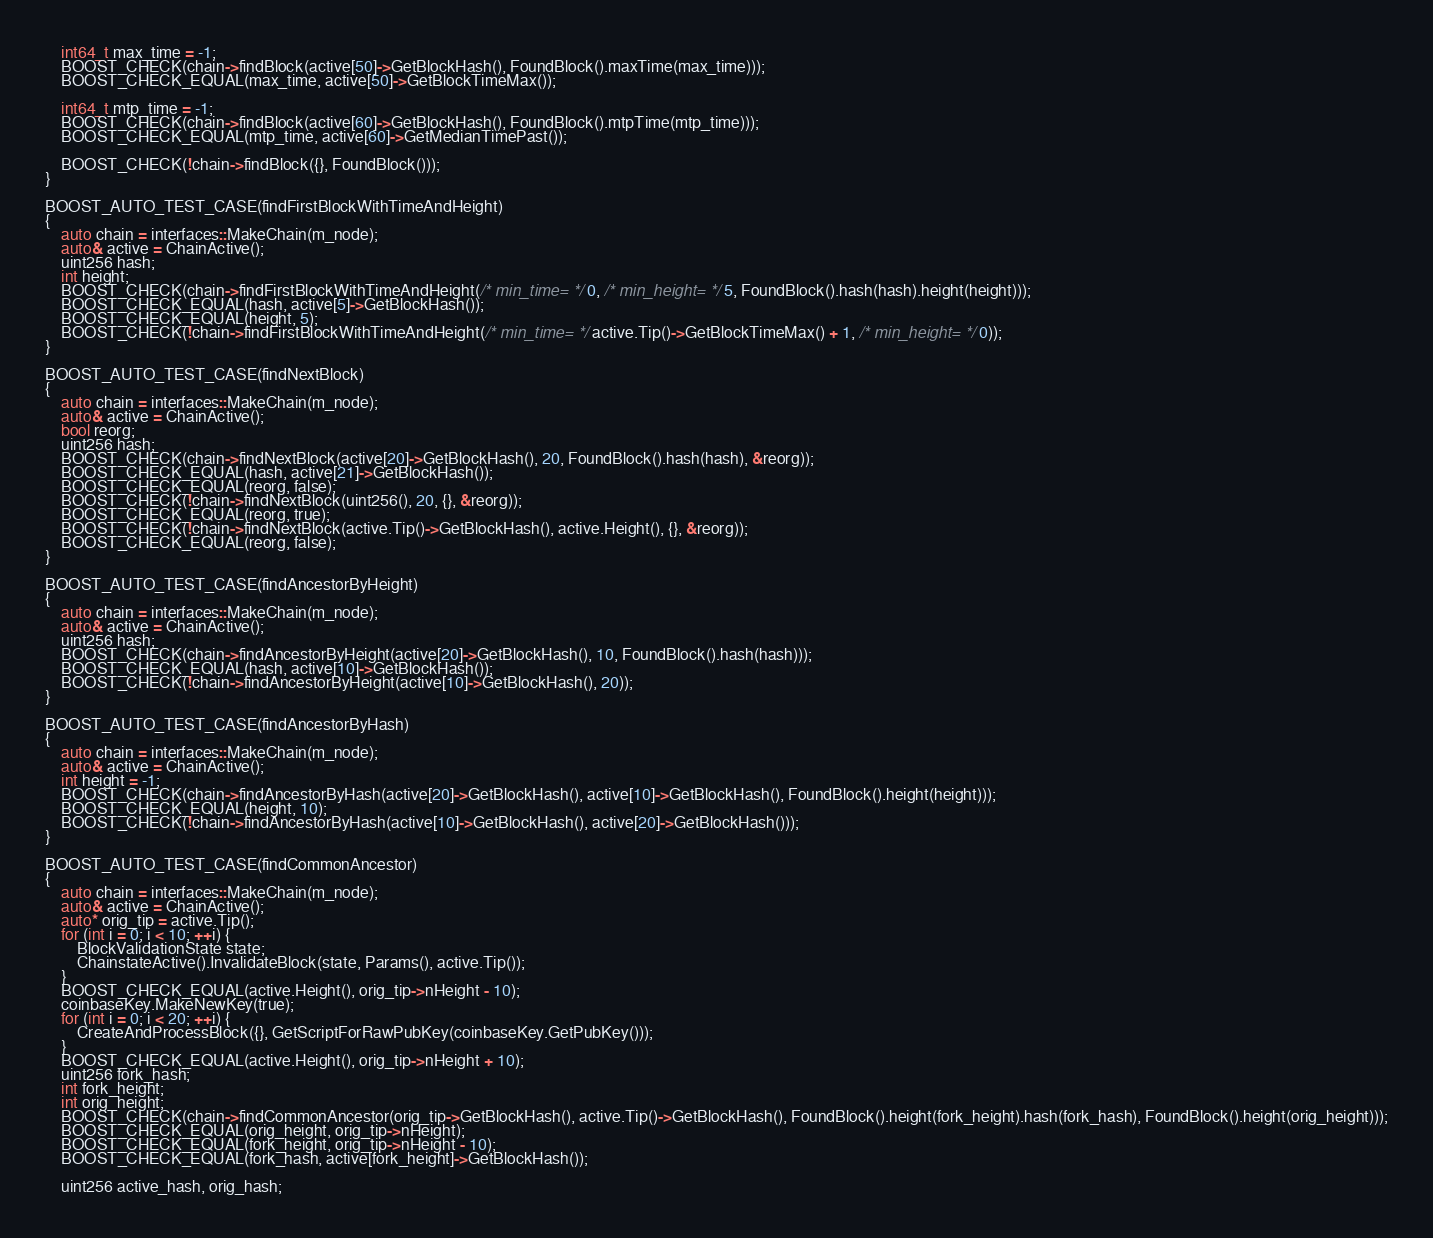Convert code to text. <code><loc_0><loc_0><loc_500><loc_500><_C++_>    int64_t max_time = -1;
    BOOST_CHECK(chain->findBlock(active[50]->GetBlockHash(), FoundBlock().maxTime(max_time)));
    BOOST_CHECK_EQUAL(max_time, active[50]->GetBlockTimeMax());

    int64_t mtp_time = -1;
    BOOST_CHECK(chain->findBlock(active[60]->GetBlockHash(), FoundBlock().mtpTime(mtp_time)));
    BOOST_CHECK_EQUAL(mtp_time, active[60]->GetMedianTimePast());

    BOOST_CHECK(!chain->findBlock({}, FoundBlock()));
}

BOOST_AUTO_TEST_CASE(findFirstBlockWithTimeAndHeight)
{
    auto chain = interfaces::MakeChain(m_node);
    auto& active = ChainActive();
    uint256 hash;
    int height;
    BOOST_CHECK(chain->findFirstBlockWithTimeAndHeight(/* min_time= */ 0, /* min_height= */ 5, FoundBlock().hash(hash).height(height)));
    BOOST_CHECK_EQUAL(hash, active[5]->GetBlockHash());
    BOOST_CHECK_EQUAL(height, 5);
    BOOST_CHECK(!chain->findFirstBlockWithTimeAndHeight(/* min_time= */ active.Tip()->GetBlockTimeMax() + 1, /* min_height= */ 0));
}

BOOST_AUTO_TEST_CASE(findNextBlock)
{
    auto chain = interfaces::MakeChain(m_node);
    auto& active = ChainActive();
    bool reorg;
    uint256 hash;
    BOOST_CHECK(chain->findNextBlock(active[20]->GetBlockHash(), 20, FoundBlock().hash(hash), &reorg));
    BOOST_CHECK_EQUAL(hash, active[21]->GetBlockHash());
    BOOST_CHECK_EQUAL(reorg, false);
    BOOST_CHECK(!chain->findNextBlock(uint256(), 20, {}, &reorg));
    BOOST_CHECK_EQUAL(reorg, true);
    BOOST_CHECK(!chain->findNextBlock(active.Tip()->GetBlockHash(), active.Height(), {}, &reorg));
    BOOST_CHECK_EQUAL(reorg, false);
}

BOOST_AUTO_TEST_CASE(findAncestorByHeight)
{
    auto chain = interfaces::MakeChain(m_node);
    auto& active = ChainActive();
    uint256 hash;
    BOOST_CHECK(chain->findAncestorByHeight(active[20]->GetBlockHash(), 10, FoundBlock().hash(hash)));
    BOOST_CHECK_EQUAL(hash, active[10]->GetBlockHash());
    BOOST_CHECK(!chain->findAncestorByHeight(active[10]->GetBlockHash(), 20));
}

BOOST_AUTO_TEST_CASE(findAncestorByHash)
{
    auto chain = interfaces::MakeChain(m_node);
    auto& active = ChainActive();
    int height = -1;
    BOOST_CHECK(chain->findAncestorByHash(active[20]->GetBlockHash(), active[10]->GetBlockHash(), FoundBlock().height(height)));
    BOOST_CHECK_EQUAL(height, 10);
    BOOST_CHECK(!chain->findAncestorByHash(active[10]->GetBlockHash(), active[20]->GetBlockHash()));
}

BOOST_AUTO_TEST_CASE(findCommonAncestor)
{
    auto chain = interfaces::MakeChain(m_node);
    auto& active = ChainActive();
    auto* orig_tip = active.Tip();
    for (int i = 0; i < 10; ++i) {
        BlockValidationState state;
        ChainstateActive().InvalidateBlock(state, Params(), active.Tip());
    }
    BOOST_CHECK_EQUAL(active.Height(), orig_tip->nHeight - 10);
    coinbaseKey.MakeNewKey(true);
    for (int i = 0; i < 20; ++i) {
        CreateAndProcessBlock({}, GetScriptForRawPubKey(coinbaseKey.GetPubKey()));
    }
    BOOST_CHECK_EQUAL(active.Height(), orig_tip->nHeight + 10);
    uint256 fork_hash;
    int fork_height;
    int orig_height;
    BOOST_CHECK(chain->findCommonAncestor(orig_tip->GetBlockHash(), active.Tip()->GetBlockHash(), FoundBlock().height(fork_height).hash(fork_hash), FoundBlock().height(orig_height)));
    BOOST_CHECK_EQUAL(orig_height, orig_tip->nHeight);
    BOOST_CHECK_EQUAL(fork_height, orig_tip->nHeight - 10);
    BOOST_CHECK_EQUAL(fork_hash, active[fork_height]->GetBlockHash());

    uint256 active_hash, orig_hash;</code> 